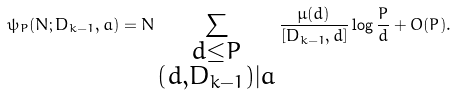Convert formula to latex. <formula><loc_0><loc_0><loc_500><loc_500>\psi _ { P } ( N ; D _ { k - 1 } , a ) = N \sum _ { \substack { d \leq P \\ ( d , D _ { k - 1 } ) | a } } \frac { \mu ( d ) } { [ D _ { k - 1 } , d ] } \log \frac { P } { d } + O ( P ) .</formula> 